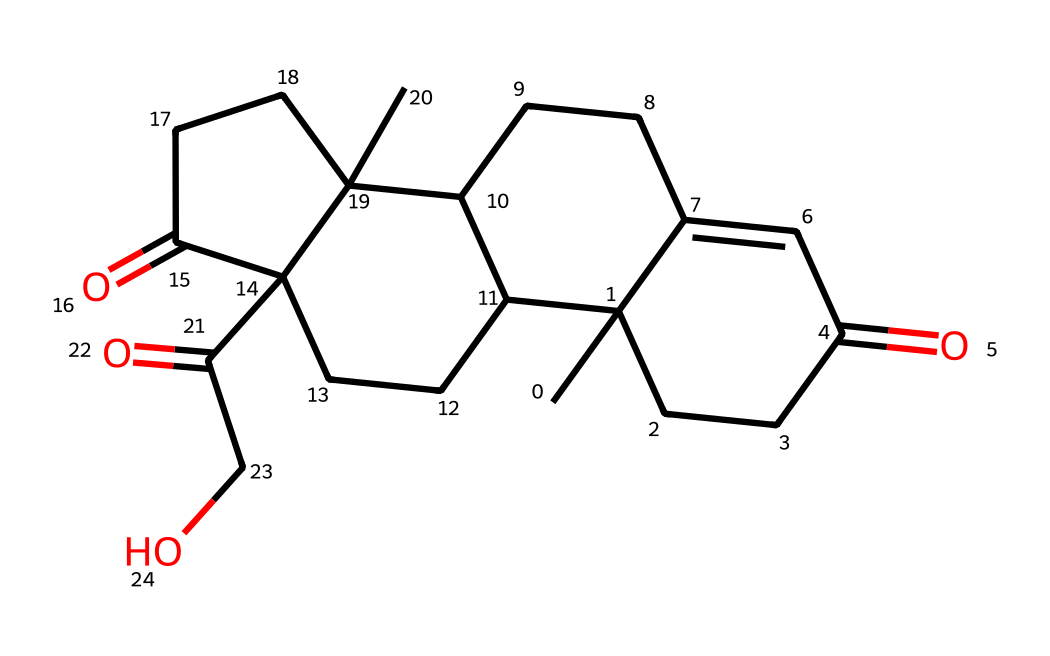What is the molecular formula of cortisol? The SMILES representation can be converted or interpreted to deduce the molecular formula. By analyzing the structure, the counts of each type of atom (carbon, hydrogen, oxygen) can be summed. The final tally shows there are 21 carbons, 30 hydrogens, and 5 oxygens.
Answer: C21H30O5 How many rings are present in the cortisol structure? By closely examining the chemical structure represented in the SMILES, we can identify that the compound consists of four fused rings. These rings are essential for the steroid nature of cortisol.
Answer: 4 What kind of biological activity does cortisol primarily facilitate? Cortisol mainly functions as a glucocorticoid hormone, playing a role in the regulation of metabolism and immune response. This biological activity is derived from its structural characteristics as a steroid.
Answer: glucocorticoid How many carbonyl (C=O) functional groups are present in cortisol? The structure revealed through the SMILES recognition indicates that there are three carbonyl groups present in cortisol. This affects its chemical behavior and biological activity significantly.
Answer: 3 What is the role of cortisol during stress? Cortisol enhances energy availability by promoting glucose metabolism and reducing inflammation during stress. This effect is made possible through its hormonal action in the body.
Answer: energy availability What type of hormone is cortisol classified as? Cortisol falls under the category of steroid hormones due to its steroidal structure, characterized by its multiple ringed formation and hydrophobic properties.
Answer: steroid hormone 